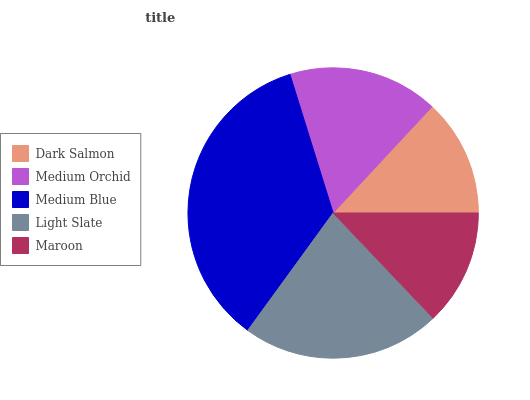Is Maroon the minimum?
Answer yes or no. Yes. Is Medium Blue the maximum?
Answer yes or no. Yes. Is Medium Orchid the minimum?
Answer yes or no. No. Is Medium Orchid the maximum?
Answer yes or no. No. Is Medium Orchid greater than Dark Salmon?
Answer yes or no. Yes. Is Dark Salmon less than Medium Orchid?
Answer yes or no. Yes. Is Dark Salmon greater than Medium Orchid?
Answer yes or no. No. Is Medium Orchid less than Dark Salmon?
Answer yes or no. No. Is Medium Orchid the high median?
Answer yes or no. Yes. Is Medium Orchid the low median?
Answer yes or no. Yes. Is Maroon the high median?
Answer yes or no. No. Is Dark Salmon the low median?
Answer yes or no. No. 